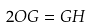Convert formula to latex. <formula><loc_0><loc_0><loc_500><loc_500>2 O G = G H</formula> 